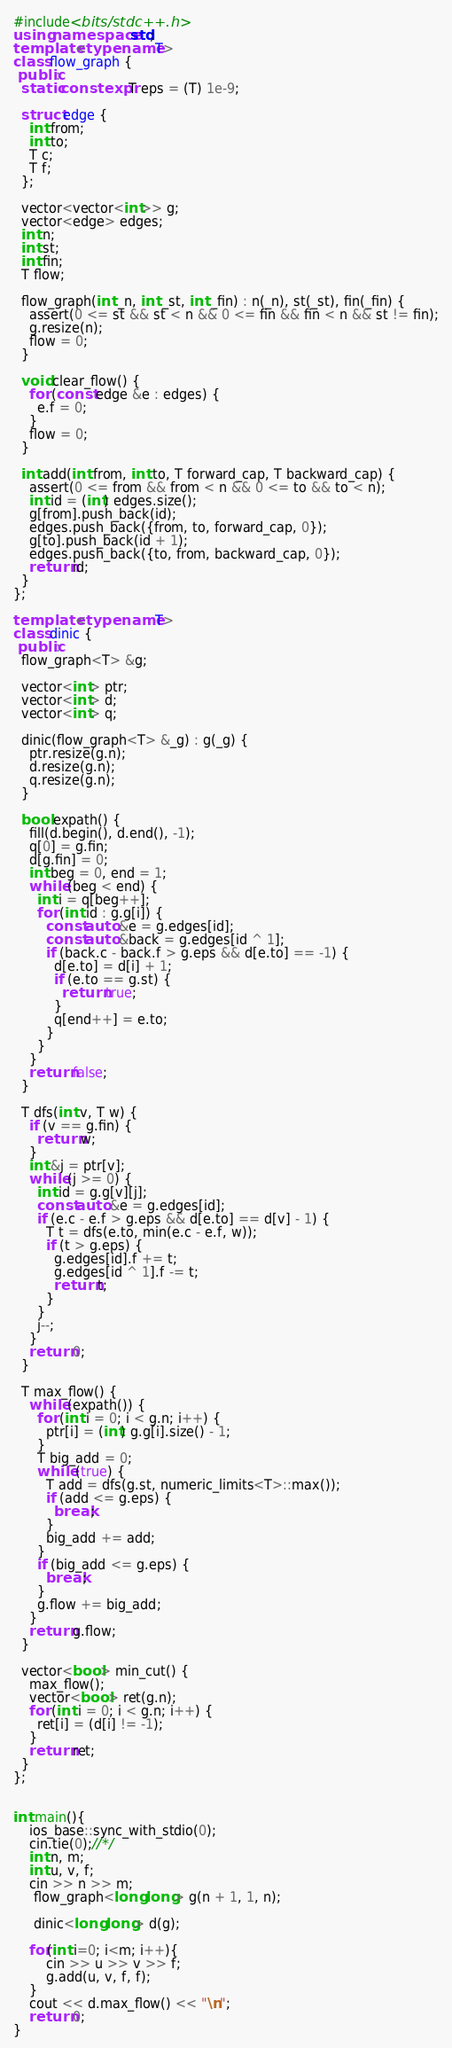<code> <loc_0><loc_0><loc_500><loc_500><_C++_>#include<bits/stdc++.h>
using namespace std;
template <typename T>
class flow_graph {
 public:
  static constexpr T eps = (T) 1e-9;
 
  struct edge {
    int from;
    int to;
    T c;
    T f;
  };
 
  vector<vector<int>> g;
  vector<edge> edges;
  int n;
  int st;
  int fin;
  T flow;
 
  flow_graph(int _n, int _st, int _fin) : n(_n), st(_st), fin(_fin) {
    assert(0 <= st && st < n && 0 <= fin && fin < n && st != fin);
    g.resize(n);
    flow = 0;
  }
 
  void clear_flow() {
    for (const edge &e : edges) {
      e.f = 0;
    }
    flow = 0;
  }
   
  int add(int from, int to, T forward_cap, T backward_cap) {
    assert(0 <= from && from < n && 0 <= to && to < n);
    int id = (int) edges.size();
    g[from].push_back(id);
    edges.push_back({from, to, forward_cap, 0});
    g[to].push_back(id + 1);
    edges.push_back({to, from, backward_cap, 0});
    return id;
  }
};
 
template <typename T>
class dinic {
 public:
  flow_graph<T> &g;
 
  vector<int> ptr;
  vector<int> d;
  vector<int> q;
 
  dinic(flow_graph<T> &_g) : g(_g) {
    ptr.resize(g.n);
    d.resize(g.n);
    q.resize(g.n);
  }
 
  bool expath() {
    fill(d.begin(), d.end(), -1);
    q[0] = g.fin;
    d[g.fin] = 0;
    int beg = 0, end = 1;
    while (beg < end) {
      int i = q[beg++];
      for (int id : g.g[i]) {
        const auto &e = g.edges[id];
        const auto &back = g.edges[id ^ 1];
        if (back.c - back.f > g.eps && d[e.to] == -1) {
          d[e.to] = d[i] + 1;
          if (e.to == g.st) {
            return true;
          }
          q[end++] = e.to;
        }
      }
    }
    return false;
  }
   
  T dfs(int v, T w) {
    if (v == g.fin) {
      return w;
    }
    int &j = ptr[v];
    while (j >= 0) {
      int id = g.g[v][j];
      const auto &e = g.edges[id];
      if (e.c - e.f > g.eps && d[e.to] == d[v] - 1) {
        T t = dfs(e.to, min(e.c - e.f, w));
        if (t > g.eps) {
          g.edges[id].f += t;
          g.edges[id ^ 1].f -= t;
          return t;
        }
      }
      j--;
    }
    return 0;
  }
 
  T max_flow() {
    while (expath()) {
      for (int i = 0; i < g.n; i++) {
        ptr[i] = (int) g.g[i].size() - 1;
      }
      T big_add = 0;
      while (true) {
        T add = dfs(g.st, numeric_limits<T>::max());
        if (add <= g.eps) {
          break;
        }
        big_add += add;
      }
      if (big_add <= g.eps) {
        break;
      }
      g.flow += big_add;
    }
    return g.flow;
  }
 
  vector<bool> min_cut() {
    max_flow();
    vector<bool> ret(g.n);
    for (int i = 0; i < g.n; i++) {
      ret[i] = (d[i] != -1);
    }
    return ret;
  }
};


int main(){
    ios_base::sync_with_stdio(0);
    cin.tie(0);//*/
    int n, m;
    int u, v, f;
    cin >> n >> m;
     flow_graph<long long> g(n + 1, 1, n);
  
     dinic<long long> d(g);

    for(int i=0; i<m; i++){
    	cin >> u >> v >> f;
    	g.add(u, v, f, f);
    }    
    cout << d.max_flow() << "\n";
    return 0;
}
</code> 